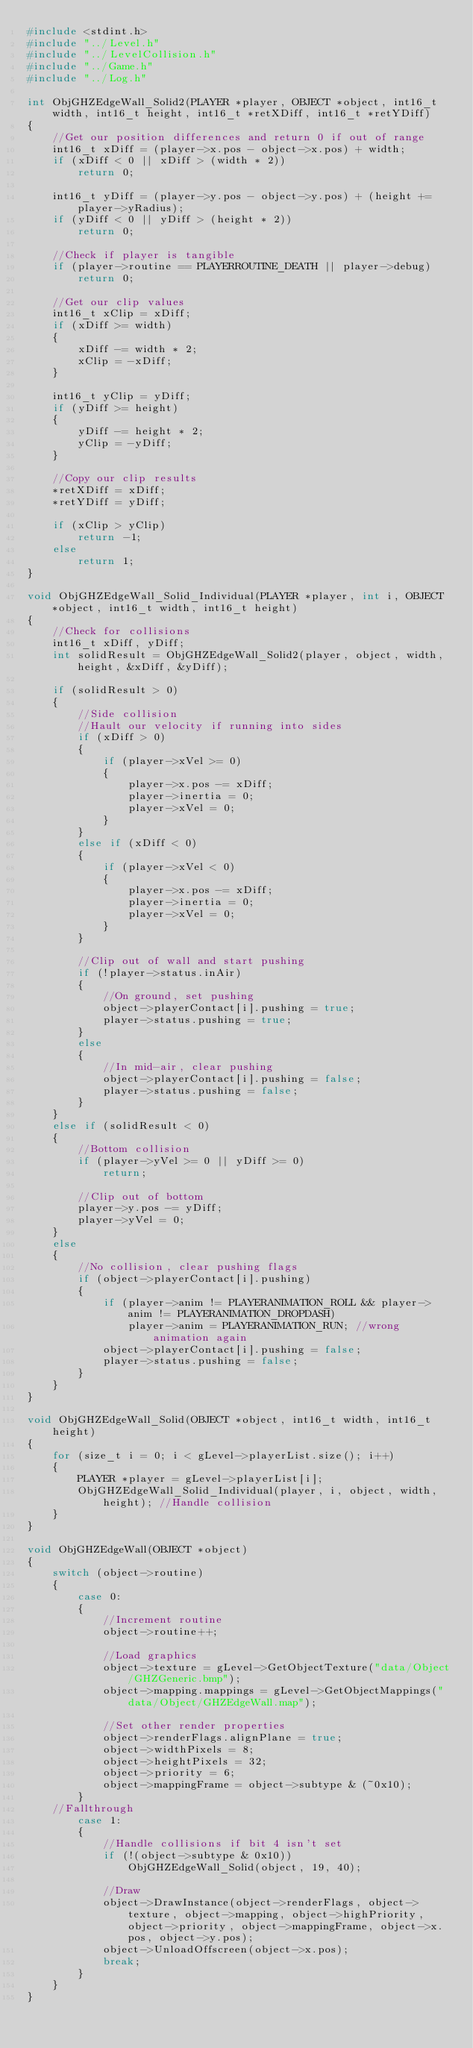<code> <loc_0><loc_0><loc_500><loc_500><_C++_>#include <stdint.h>
#include "../Level.h"
#include "../LevelCollision.h"
#include "../Game.h"
#include "../Log.h"

int ObjGHZEdgeWall_Solid2(PLAYER *player, OBJECT *object, int16_t width, int16_t height, int16_t *retXDiff, int16_t *retYDiff)
{
	//Get our position differences and return 0 if out of range
	int16_t xDiff = (player->x.pos - object->x.pos) + width;
	if (xDiff < 0 || xDiff > (width * 2))
		return 0;
	
	int16_t yDiff = (player->y.pos - object->y.pos) + (height += player->yRadius);
	if (yDiff < 0 || yDiff > (height * 2))
		return 0;
	
	//Check if player is tangible
	if (player->routine == PLAYERROUTINE_DEATH || player->debug)
		return 0;
	
	//Get our clip values
	int16_t xClip = xDiff;
	if (xDiff >= width)
	{
		xDiff -= width * 2;
		xClip = -xDiff;
	}
	
	int16_t yClip = yDiff;
	if (yDiff >= height)
	{
		yDiff -= height * 2;
		yClip = -yDiff;
	}
	
	//Copy our clip results
	*retXDiff = xDiff;
	*retYDiff = yDiff;
	
	if (xClip > yClip)
		return -1;
	else
		return 1;
}

void ObjGHZEdgeWall_Solid_Individual(PLAYER *player, int i, OBJECT *object, int16_t width, int16_t height)
{
	//Check for collisions
	int16_t xDiff, yDiff;
	int solidResult = ObjGHZEdgeWall_Solid2(player, object, width, height, &xDiff, &yDiff);
	
	if (solidResult > 0)
	{
		//Side collision
		//Hault our velocity if running into sides
		if (xDiff > 0)
		{
			if (player->xVel >= 0)
			{
				player->x.pos -= xDiff;
				player->inertia = 0;
				player->xVel = 0;
			}
		}
		else if (xDiff < 0)
		{
			if (player->xVel < 0)
			{
				player->x.pos -= xDiff;
				player->inertia = 0;
				player->xVel = 0;
			}
		}
		
		//Clip out of wall and start pushing
		if (!player->status.inAir)
		{
			//On ground, set pushing
			object->playerContact[i].pushing = true;
			player->status.pushing = true;
		}
		else
		{
			//In mid-air, clear pushing
			object->playerContact[i].pushing = false;
			player->status.pushing = false;
		}
	}
	else if (solidResult < 0)
	{
		//Bottom collision
		if (player->yVel >= 0 || yDiff >= 0)
			return;
		
		//Clip out of bottom
		player->y.pos -= yDiff;
		player->yVel = 0;
	}
	else
	{
		//No collision, clear pushing flags
		if (object->playerContact[i].pushing)
		{
			if (player->anim != PLAYERANIMATION_ROLL && player->anim != PLAYERANIMATION_DROPDASH)
				player->anim = PLAYERANIMATION_RUN; //wrong animation again
			object->playerContact[i].pushing = false;
			player->status.pushing = false;
		}
	}
}

void ObjGHZEdgeWall_Solid(OBJECT *object, int16_t width, int16_t height)
{
	for (size_t i = 0; i < gLevel->playerList.size(); i++)
	{
		PLAYER *player = gLevel->playerList[i];
		ObjGHZEdgeWall_Solid_Individual(player, i, object, width, height); //Handle collision
	}
}

void ObjGHZEdgeWall(OBJECT *object)
{
	switch (object->routine)
	{
		case 0:
		{
			//Increment routine
			object->routine++;
			
			//Load graphics
			object->texture = gLevel->GetObjectTexture("data/Object/GHZGeneric.bmp");
			object->mapping.mappings = gLevel->GetObjectMappings("data/Object/GHZEdgeWall.map");
			
			//Set other render properties
			object->renderFlags.alignPlane = true;
			object->widthPixels = 8;
			object->heightPixels = 32;
			object->priority = 6;
			object->mappingFrame = object->subtype & (~0x10);
		}
	//Fallthrough
		case 1:
		{
			//Handle collisions if bit 4 isn't set
			if (!(object->subtype & 0x10))
				ObjGHZEdgeWall_Solid(object, 19, 40);
			
			//Draw
			object->DrawInstance(object->renderFlags, object->texture, object->mapping, object->highPriority, object->priority, object->mappingFrame, object->x.pos, object->y.pos);
			object->UnloadOffscreen(object->x.pos);
			break;
		}
	}
}
</code> 